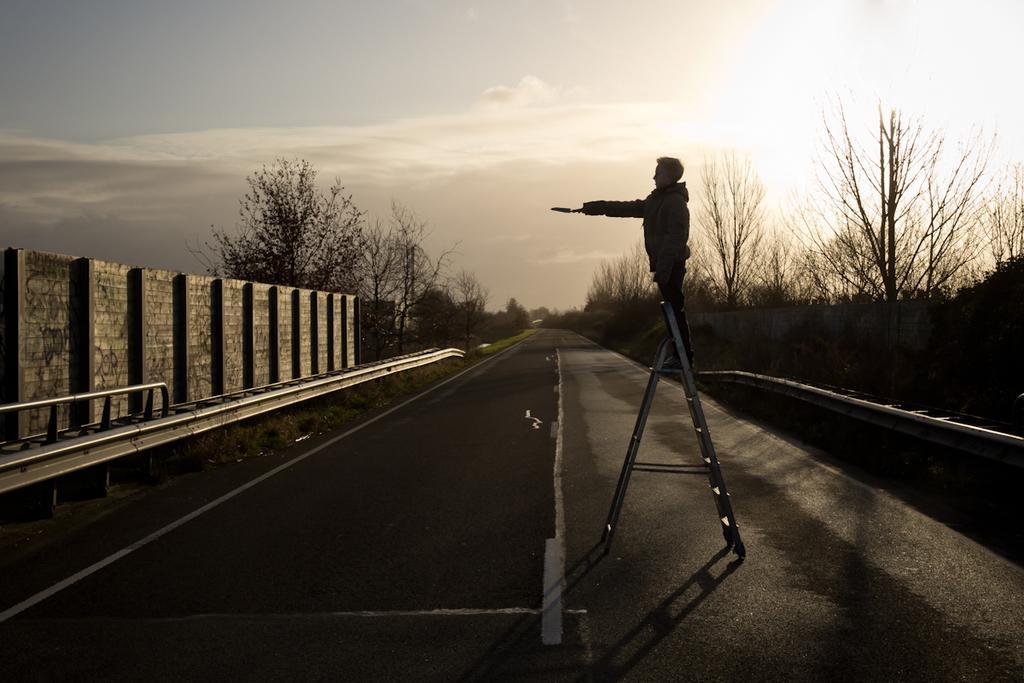Could you give a brief overview of what you see in this image? In this image, we can see a person holding an object is standing on a ladder. We can see the ground. There are a few trees. We can see some grass and the sky with clouds. 